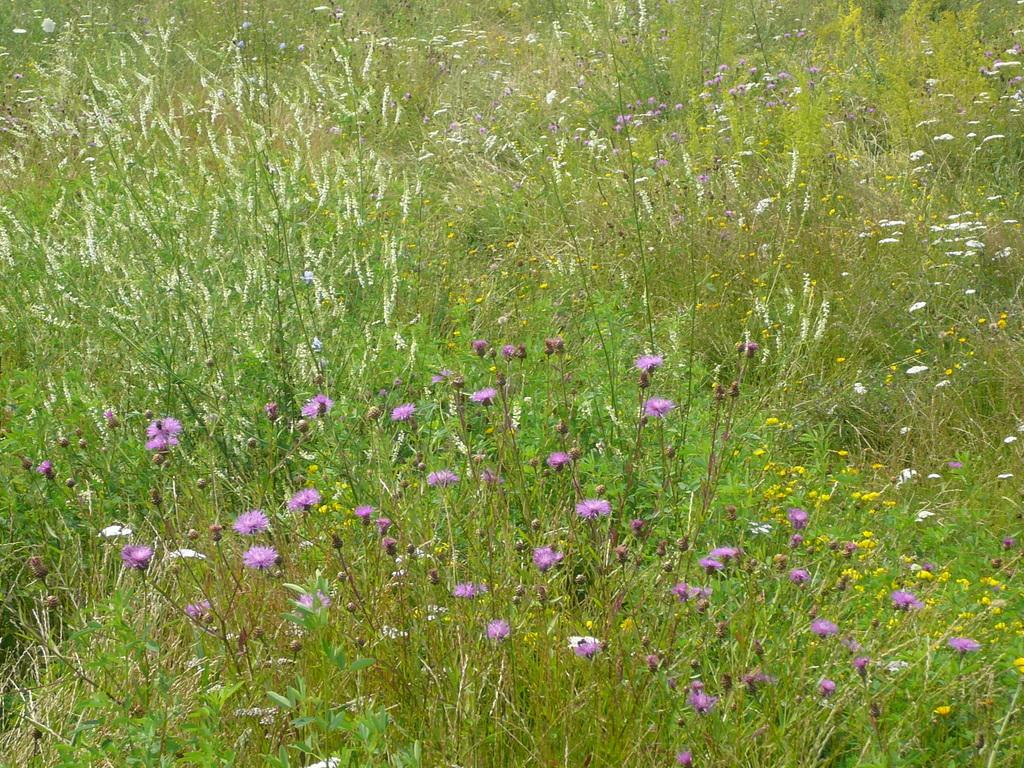What type of landscape is depicted at the bottom side of the image? There is a flower field at the bottom side of the image. What can be observed in the surrounding area of the image? There is greenery around the area of the image. What type of party is happening in the flower field in the image? There is no party happening in the flower field in the image. Can you see any ice in the flower field or surrounding greenery? There is no ice present in the flower field or surrounding greenery in the image. 